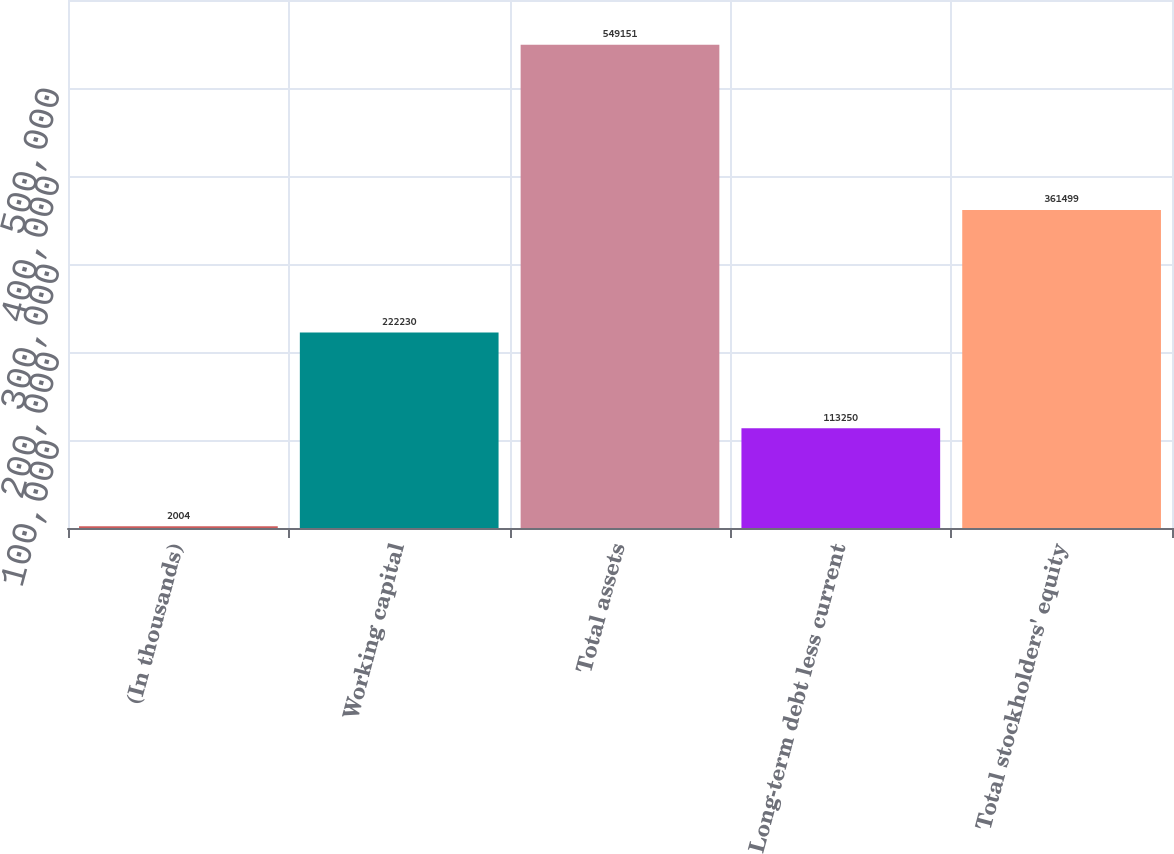Convert chart to OTSL. <chart><loc_0><loc_0><loc_500><loc_500><bar_chart><fcel>(In thousands)<fcel>Working capital<fcel>Total assets<fcel>Long-term debt less current<fcel>Total stockholders' equity<nl><fcel>2004<fcel>222230<fcel>549151<fcel>113250<fcel>361499<nl></chart> 